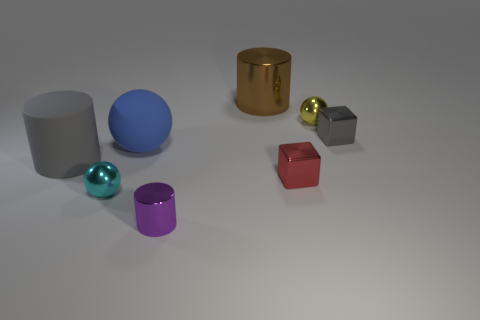How many objects are there in total, and could you categorize them by shape? In the image, there are a total of seven objects. Categorizing them by shape, we have three cylinders, two cubes, and two spheres. 